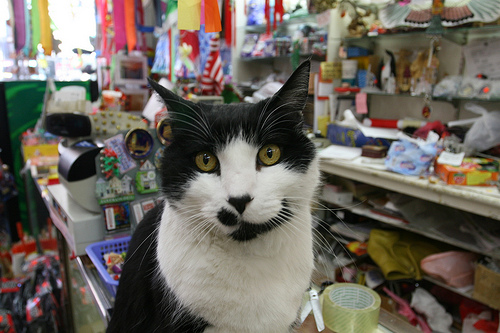<image>
Is there a cat on the shelf? No. The cat is not positioned on the shelf. They may be near each other, but the cat is not supported by or resting on top of the shelf. Is there a tape behind the cat? Yes. From this viewpoint, the tape is positioned behind the cat, with the cat partially or fully occluding the tape. 